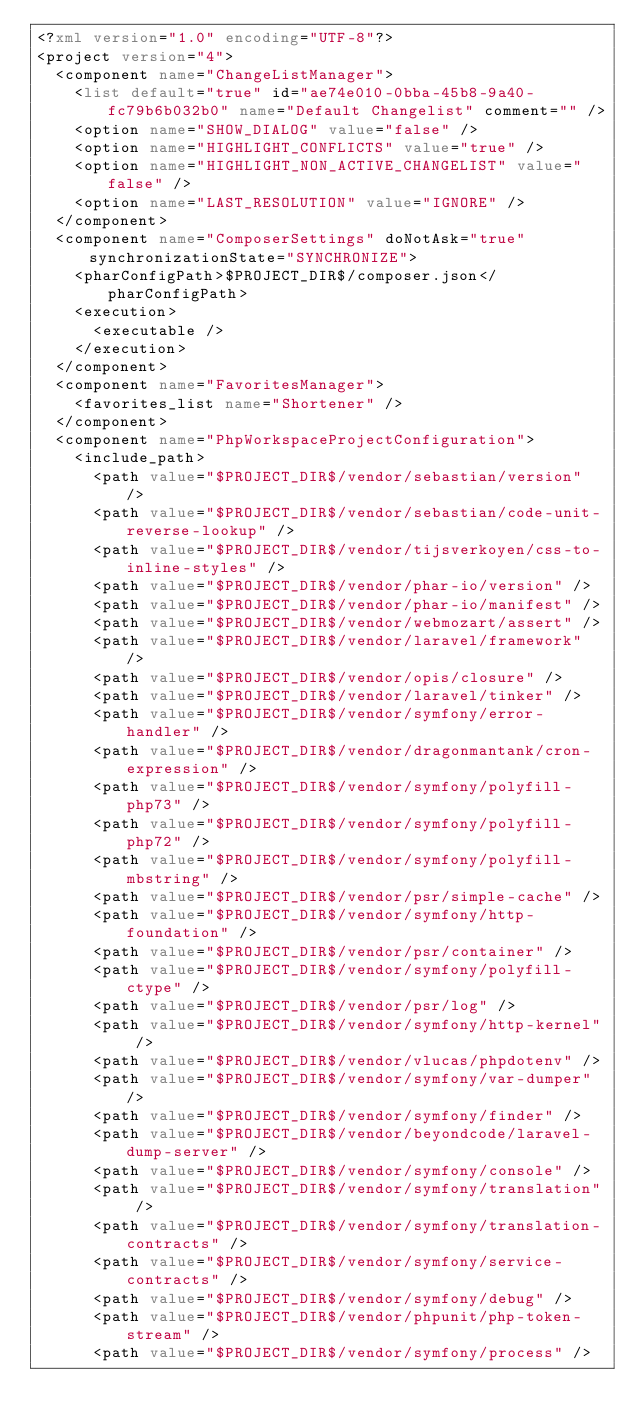<code> <loc_0><loc_0><loc_500><loc_500><_XML_><?xml version="1.0" encoding="UTF-8"?>
<project version="4">
  <component name="ChangeListManager">
    <list default="true" id="ae74e010-0bba-45b8-9a40-fc79b6b032b0" name="Default Changelist" comment="" />
    <option name="SHOW_DIALOG" value="false" />
    <option name="HIGHLIGHT_CONFLICTS" value="true" />
    <option name="HIGHLIGHT_NON_ACTIVE_CHANGELIST" value="false" />
    <option name="LAST_RESOLUTION" value="IGNORE" />
  </component>
  <component name="ComposerSettings" doNotAsk="true" synchronizationState="SYNCHRONIZE">
    <pharConfigPath>$PROJECT_DIR$/composer.json</pharConfigPath>
    <execution>
      <executable />
    </execution>
  </component>
  <component name="FavoritesManager">
    <favorites_list name="Shortener" />
  </component>
  <component name="PhpWorkspaceProjectConfiguration">
    <include_path>
      <path value="$PROJECT_DIR$/vendor/sebastian/version" />
      <path value="$PROJECT_DIR$/vendor/sebastian/code-unit-reverse-lookup" />
      <path value="$PROJECT_DIR$/vendor/tijsverkoyen/css-to-inline-styles" />
      <path value="$PROJECT_DIR$/vendor/phar-io/version" />
      <path value="$PROJECT_DIR$/vendor/phar-io/manifest" />
      <path value="$PROJECT_DIR$/vendor/webmozart/assert" />
      <path value="$PROJECT_DIR$/vendor/laravel/framework" />
      <path value="$PROJECT_DIR$/vendor/opis/closure" />
      <path value="$PROJECT_DIR$/vendor/laravel/tinker" />
      <path value="$PROJECT_DIR$/vendor/symfony/error-handler" />
      <path value="$PROJECT_DIR$/vendor/dragonmantank/cron-expression" />
      <path value="$PROJECT_DIR$/vendor/symfony/polyfill-php73" />
      <path value="$PROJECT_DIR$/vendor/symfony/polyfill-php72" />
      <path value="$PROJECT_DIR$/vendor/symfony/polyfill-mbstring" />
      <path value="$PROJECT_DIR$/vendor/psr/simple-cache" />
      <path value="$PROJECT_DIR$/vendor/symfony/http-foundation" />
      <path value="$PROJECT_DIR$/vendor/psr/container" />
      <path value="$PROJECT_DIR$/vendor/symfony/polyfill-ctype" />
      <path value="$PROJECT_DIR$/vendor/psr/log" />
      <path value="$PROJECT_DIR$/vendor/symfony/http-kernel" />
      <path value="$PROJECT_DIR$/vendor/vlucas/phpdotenv" />
      <path value="$PROJECT_DIR$/vendor/symfony/var-dumper" />
      <path value="$PROJECT_DIR$/vendor/symfony/finder" />
      <path value="$PROJECT_DIR$/vendor/beyondcode/laravel-dump-server" />
      <path value="$PROJECT_DIR$/vendor/symfony/console" />
      <path value="$PROJECT_DIR$/vendor/symfony/translation" />
      <path value="$PROJECT_DIR$/vendor/symfony/translation-contracts" />
      <path value="$PROJECT_DIR$/vendor/symfony/service-contracts" />
      <path value="$PROJECT_DIR$/vendor/symfony/debug" />
      <path value="$PROJECT_DIR$/vendor/phpunit/php-token-stream" />
      <path value="$PROJECT_DIR$/vendor/symfony/process" /></code> 